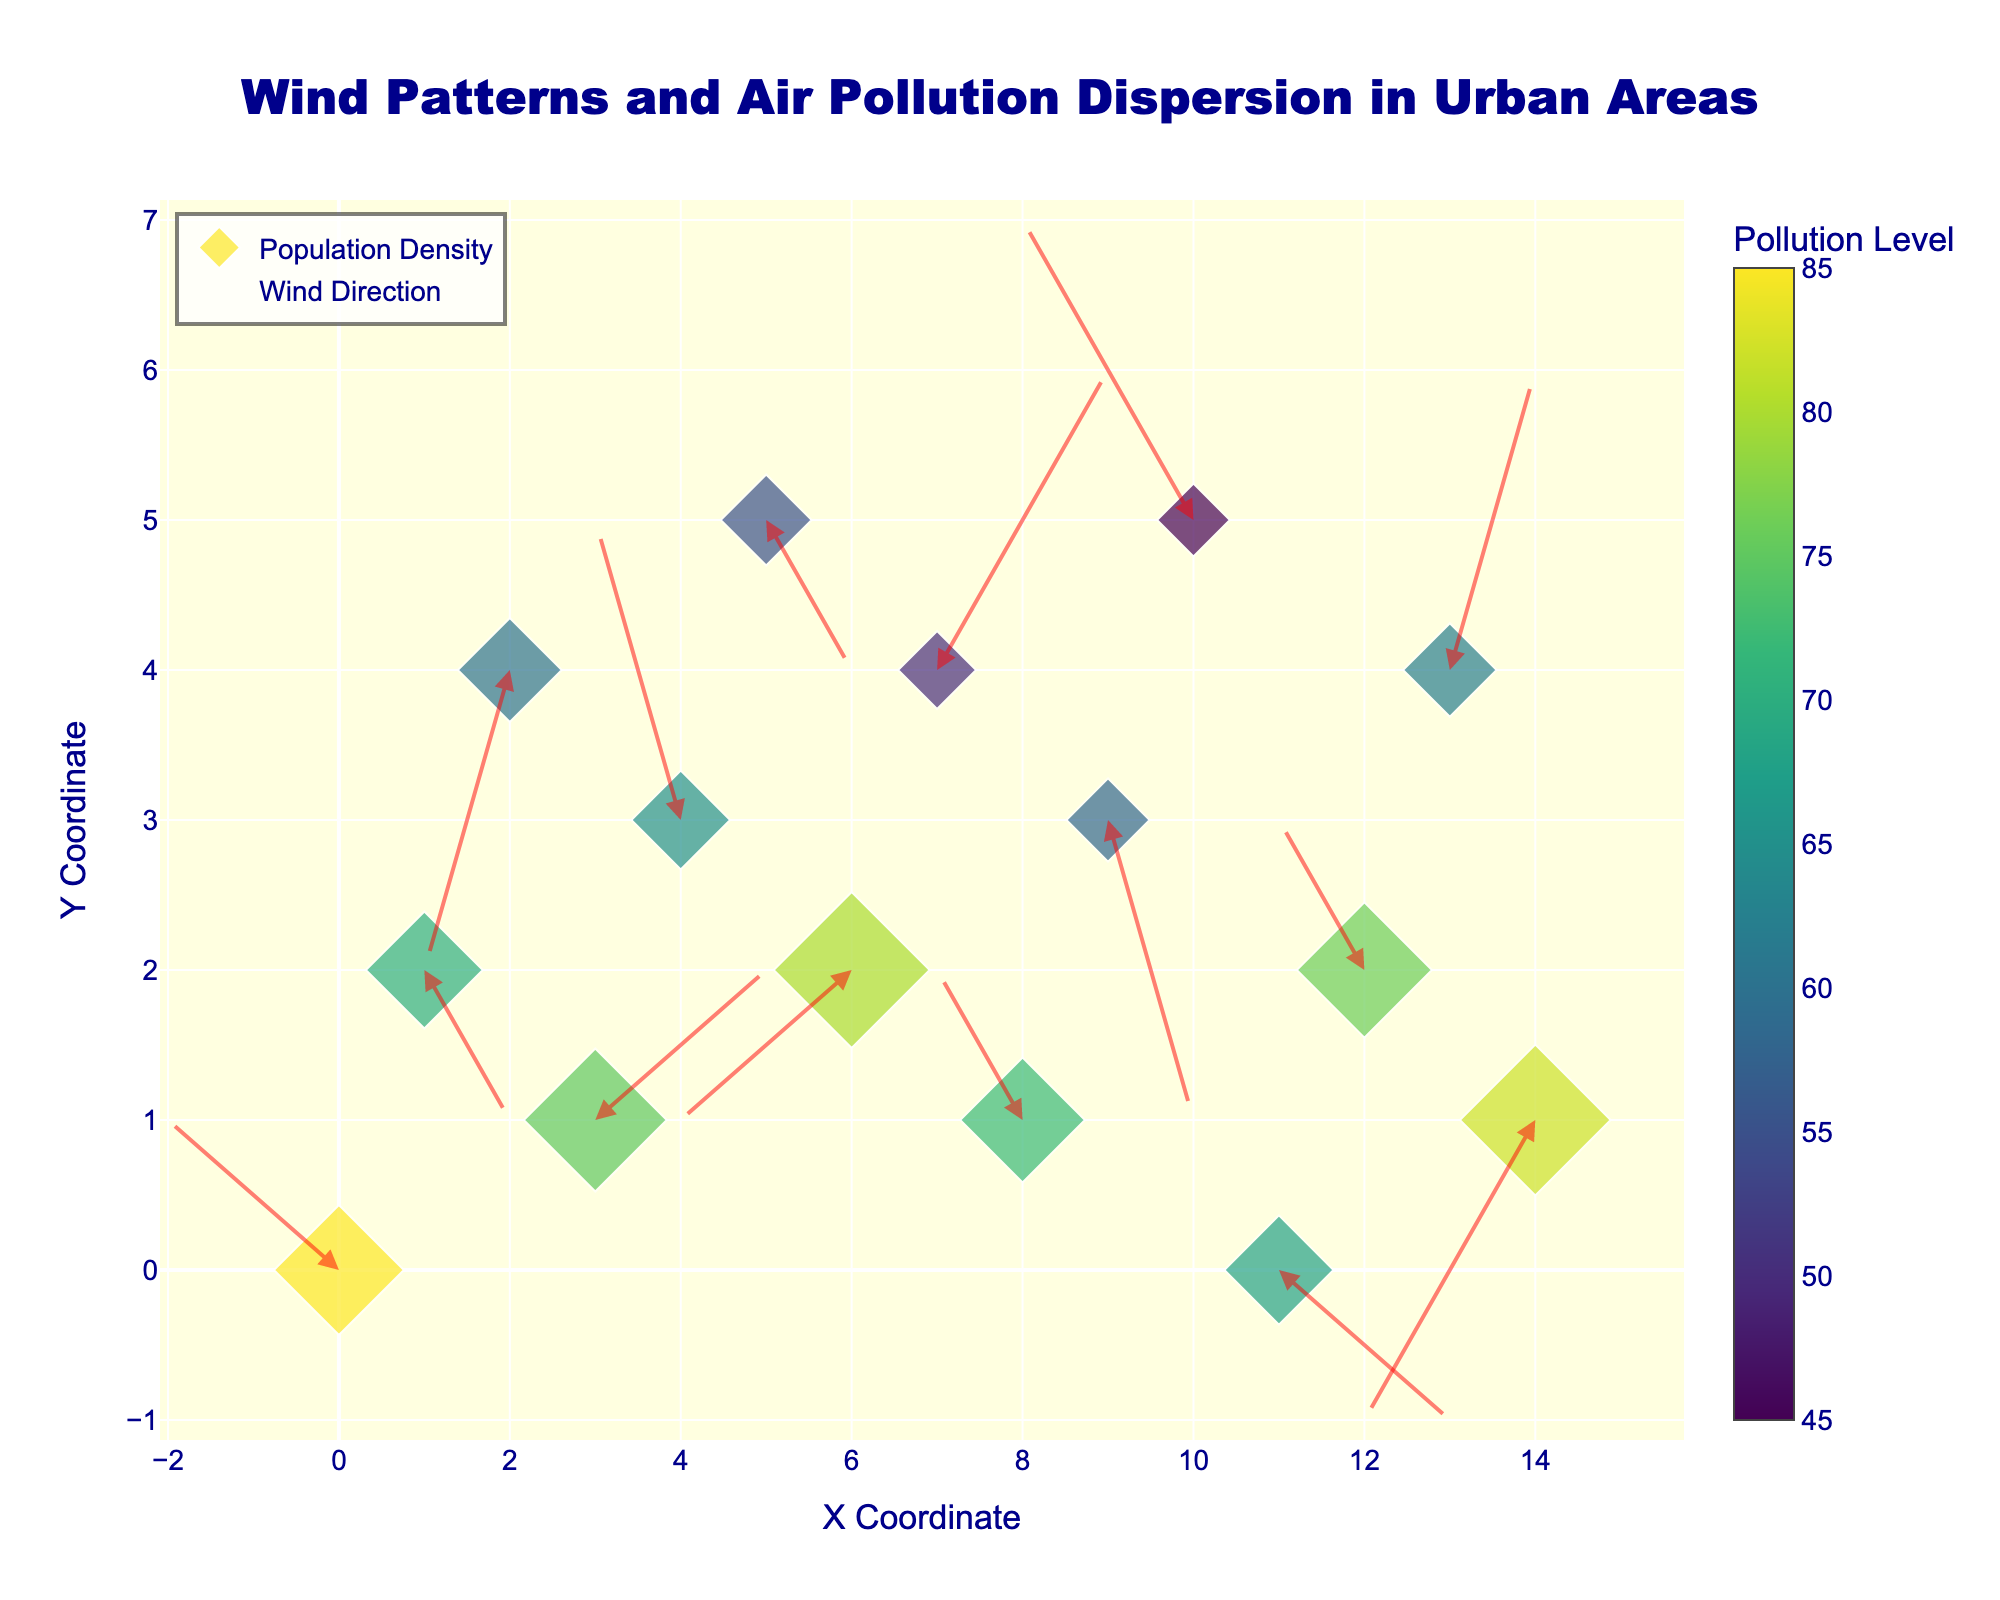How many data points are shown in the figure? There are 15 unique coordinate points (x, y) visible in the quiver plot. Counting these points gives us the total number of data points.
Answer: 15 Which location has the highest wind speed, and what is it? The wind speed can be calculated by the Euclidean norm sqrt(u^2 + v^2). For each point: (0,0): 2.24; (1,2): 1.41; (2,4): 2.24; (3,1): 2.24; (4,3): 2.24; (5,5): 1.41; (6,2): 2.24; (7,4): 2.83; (8,1): 1.41; (9,3): 2.24; (10,5): 2.83; (11,0): 2.24; (12,2): 1.41; (13,4): 2.24; (14,1): 2.83. The highest wind speed is 2.83 at (7,4), (10,5), and (14,1).
Answer: 2.83 at (7,4), (10,5), and (14,1) Which data point has the highest pollution level, and what is its value? Looking at the color scale, the pollution levels are indicated by color intensity. The data point with the highest pollution level is (0,0) with a pollution level of 85.
Answer: 85 at (0,0) How does population density correlate with pollution levels in the figure? By visually inspecting the figure, areas with denser populations (larger markers) generally have higher pollution levels (darker colors).
Answer: Higher density generally correlates with higher pollution Where is the wind blowing towards at the point with coordinates (4,3), and is this associated with a high or low pollution level? At (4,3), the wind vector is (-1, 2), indicating the wind is blowing towards (-1, 2) from the point. The pollution level at this location is 65, which is moderate.
Answer: Towards (-1, 2), moderate pollution What is the sum of pollution levels at all data points? Summing the pollution levels: 85 + 70 + 60 + 75 + 65 + 55 + 80 + 50 + 72 + 58 + 45 + 68 + 76 + 62 + 82 equals 1003.
Answer: 1003 Which coordinates show the highest population density, and what is its value? Looking at the size of the markers, the data point with the largest marker indicates the highest population density. The highest population density is 6000 at (6,2).
Answer: 6000 at (6,2) Are there any data points where the wind direction is purely horizontal or vertical? Wind direction is purely horizontal if v=0 and purely vertical if u=0. Scanning the data, at (1,2) u=1, v=-1; at (5,5) u=1, v=-1; hence, no purely horizontal or vertical wind directions.
Answer: No Which region is likely to be the most affected by health risks due to high pollution and high population density? The region (0,0) has the highest pollution level (85) and a high population density (5000), making it the most likely to be affected by health risks.
Answer: (0,0) How many locations have pollution levels higher than 70? Scanning the pollution levels, those higher than 70 are at (0,0), (6,2), (8,1), (12,2), and (14,1). Thus, 5 locations have pollution levels higher than 70.
Answer: 5 